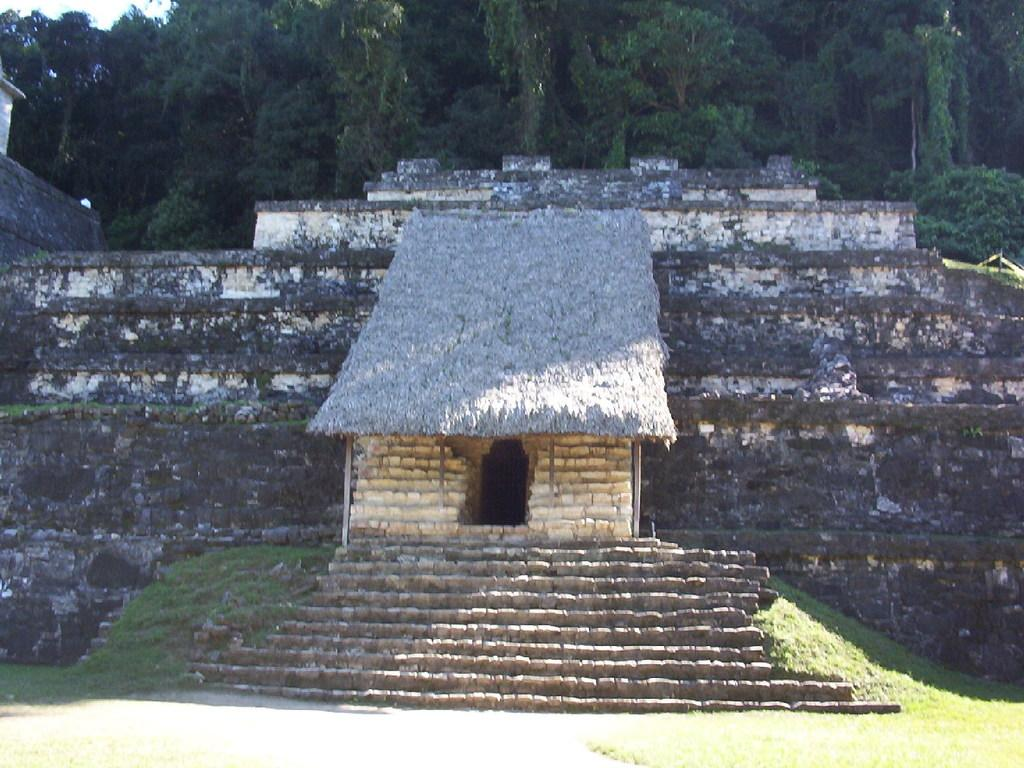What type of structure is visible in the image? There is a hut in the image. Are there any architectural features present in the image? Yes, there are steps in the image. What type of ground surface is visible in the image? There is grass in the image. What type of material is used for the walls of the hut? There are stone walls in the image. What type of vegetation is present in the image? There are trees in the image. Can you see a person trying to smash the string in the image? There is no person or string present in the image. 